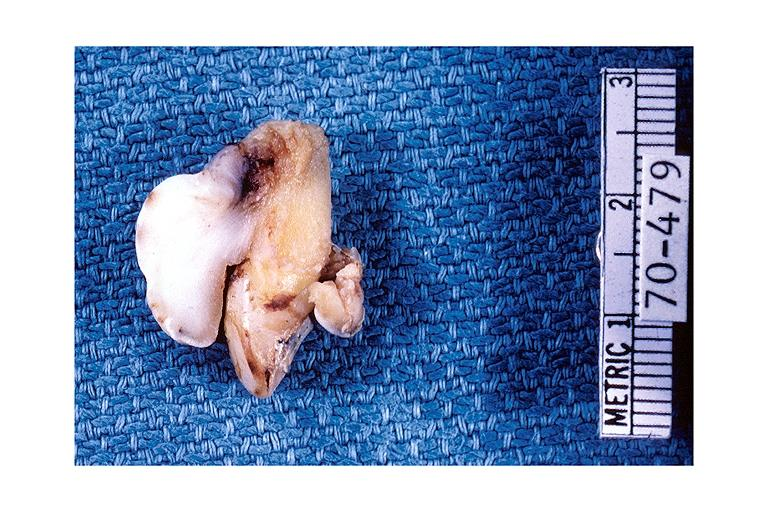does this image show periodontal fibroma?
Answer the question using a single word or phrase. Yes 